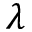<formula> <loc_0><loc_0><loc_500><loc_500>\lambda</formula> 